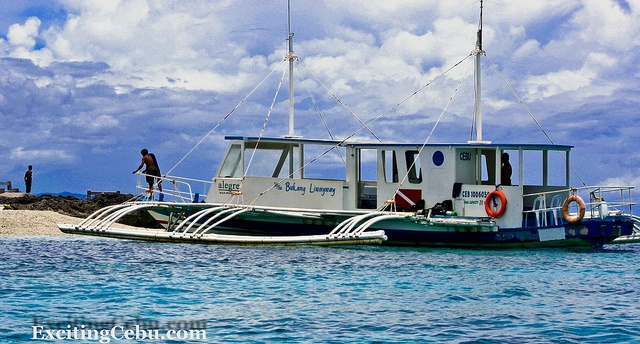Describe the objects in this image and their specific colors. I can see boat in darkgray, black, and gray tones, people in darkgray, black, maroon, and gray tones, people in darkgray, black, purple, and gray tones, and people in darkgray, black, navy, and gray tones in this image. 